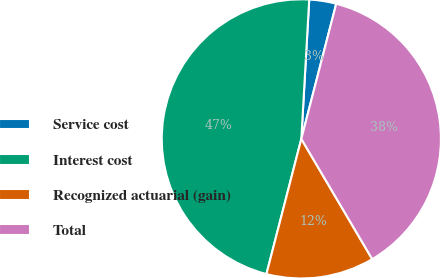Convert chart. <chart><loc_0><loc_0><loc_500><loc_500><pie_chart><fcel>Service cost<fcel>Interest cost<fcel>Recognized actuarial (gain)<fcel>Total<nl><fcel>3.12%<fcel>46.88%<fcel>12.5%<fcel>37.5%<nl></chart> 